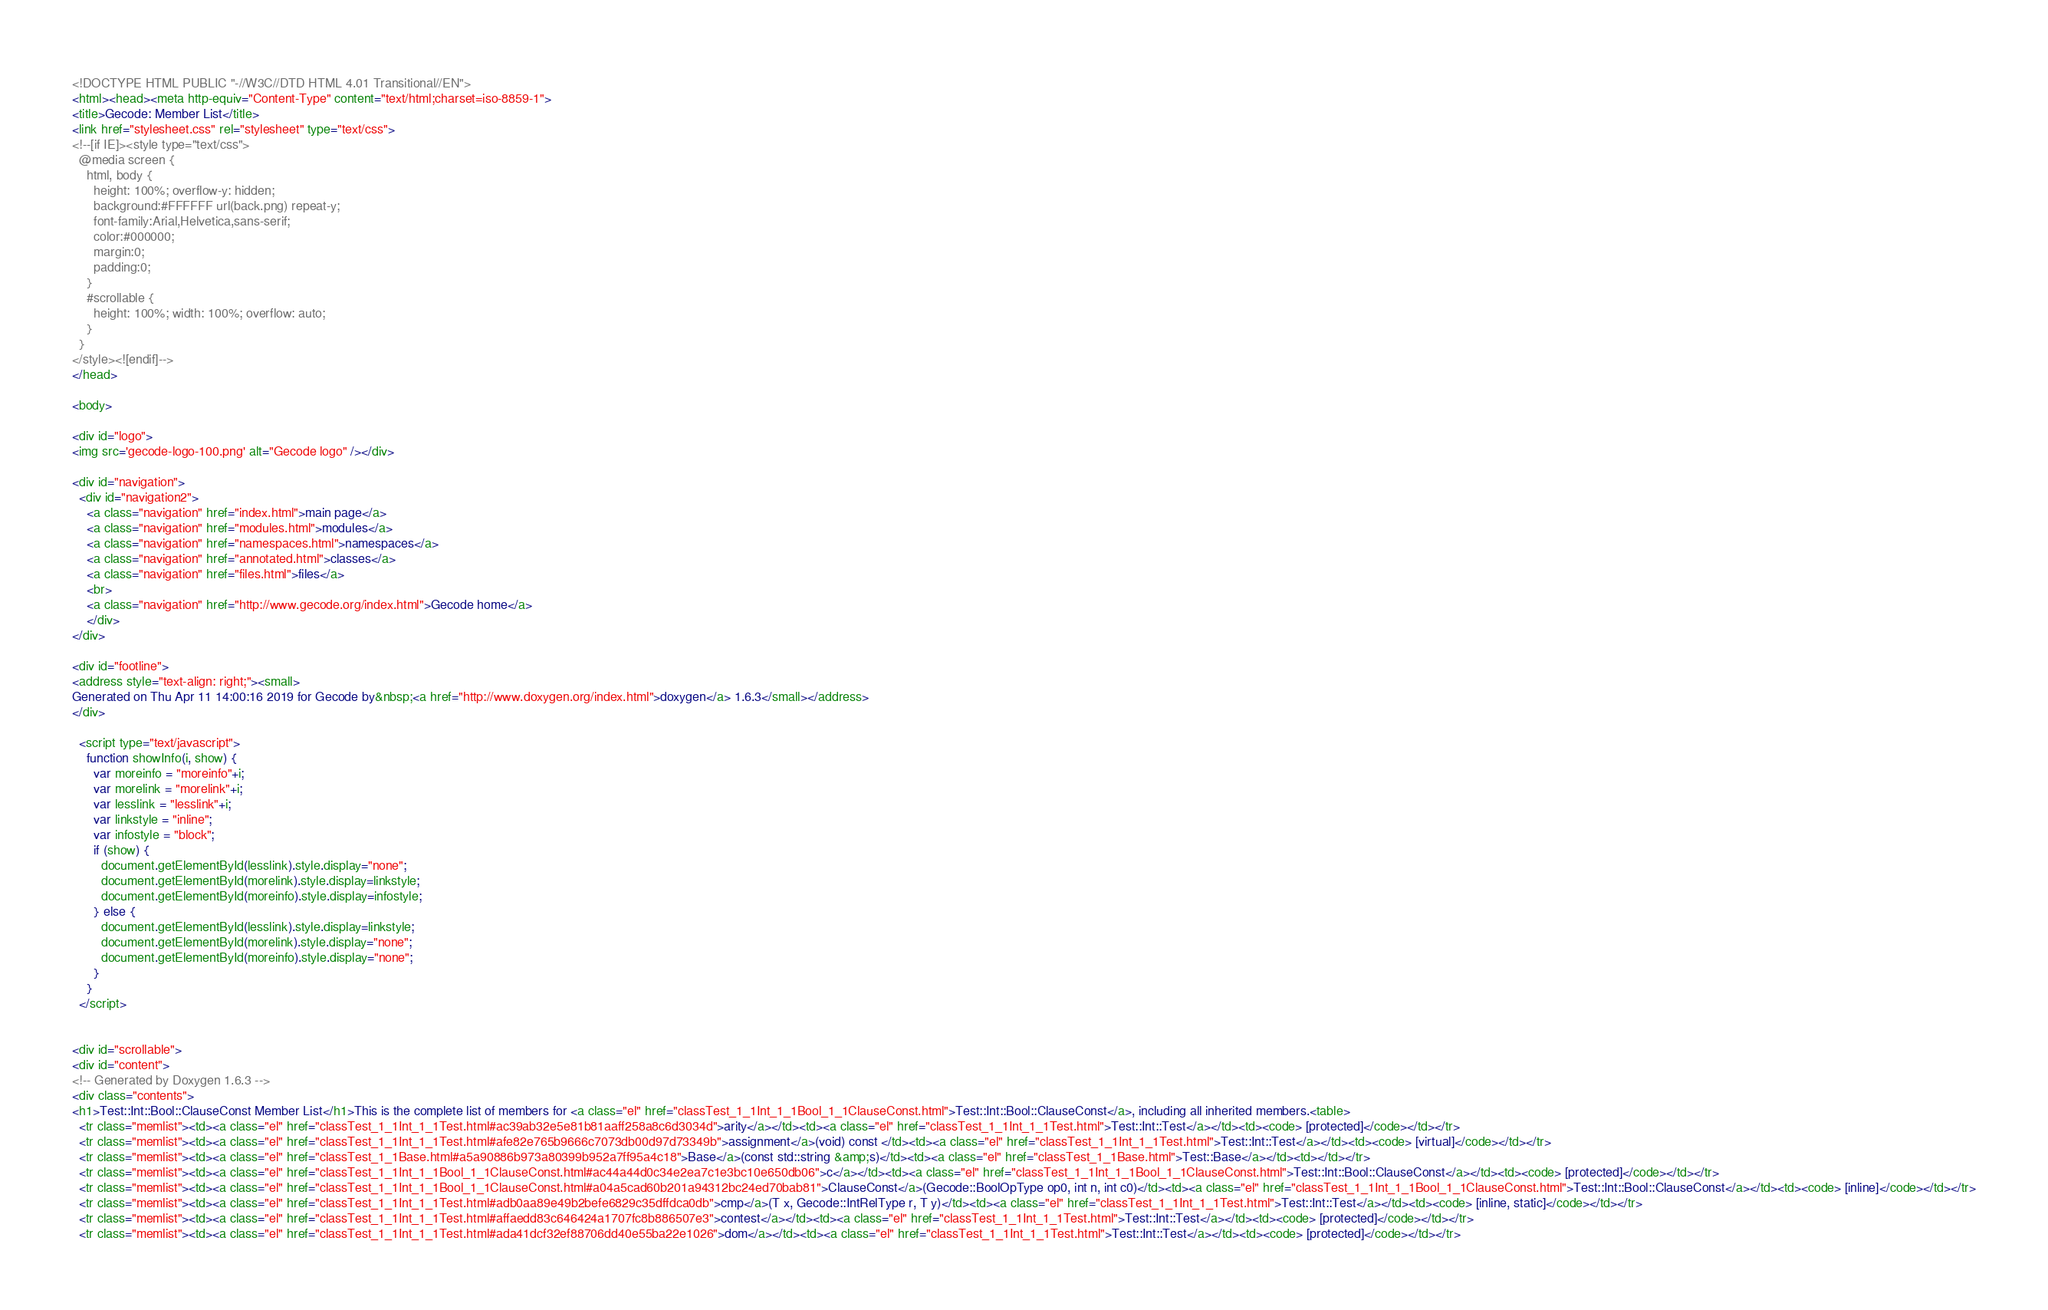Convert code to text. <code><loc_0><loc_0><loc_500><loc_500><_HTML_><!DOCTYPE HTML PUBLIC "-//W3C//DTD HTML 4.01 Transitional//EN">
<html><head><meta http-equiv="Content-Type" content="text/html;charset=iso-8859-1">
<title>Gecode: Member List</title>
<link href="stylesheet.css" rel="stylesheet" type="text/css">
<!--[if IE]><style type="text/css">
  @media screen {
    html, body {
      height: 100%; overflow-y: hidden;
      background:#FFFFFF url(back.png) repeat-y;
      font-family:Arial,Helvetica,sans-serif;
      color:#000000;
      margin:0;
      padding:0;
    }
    #scrollable {
      height: 100%; width: 100%; overflow: auto;
    }
  }
</style><![endif]-->
</head>

<body>

<div id="logo">
<img src='gecode-logo-100.png' alt="Gecode logo" /></div>

<div id="navigation">
  <div id="navigation2">
    <a class="navigation" href="index.html">main page</a>
    <a class="navigation" href="modules.html">modules</a>
    <a class="navigation" href="namespaces.html">namespaces</a>
    <a class="navigation" href="annotated.html">classes</a>
    <a class="navigation" href="files.html">files</a>
    <br>
    <a class="navigation" href="http://www.gecode.org/index.html">Gecode home</a>
    </div>
</div>

<div id="footline">
<address style="text-align: right;"><small>
Generated on Thu Apr 11 14:00:16 2019 for Gecode by&nbsp;<a href="http://www.doxygen.org/index.html">doxygen</a> 1.6.3</small></address>
</div>

  <script type="text/javascript">
    function showInfo(i, show) {
      var moreinfo = "moreinfo"+i;
      var morelink = "morelink"+i;
      var lesslink = "lesslink"+i;
      var linkstyle = "inline";
      var infostyle = "block";
      if (show) {
        document.getElementById(lesslink).style.display="none";
        document.getElementById(morelink).style.display=linkstyle;
        document.getElementById(moreinfo).style.display=infostyle;
      } else {
        document.getElementById(lesslink).style.display=linkstyle;
        document.getElementById(morelink).style.display="none";
        document.getElementById(moreinfo).style.display="none";
      }
    }
  </script>


<div id="scrollable">
<div id="content">
<!-- Generated by Doxygen 1.6.3 -->
<div class="contents">
<h1>Test::Int::Bool::ClauseConst Member List</h1>This is the complete list of members for <a class="el" href="classTest_1_1Int_1_1Bool_1_1ClauseConst.html">Test::Int::Bool::ClauseConst</a>, including all inherited members.<table>
  <tr class="memlist"><td><a class="el" href="classTest_1_1Int_1_1Test.html#ac39ab32e5e81b81aaff258a8c6d3034d">arity</a></td><td><a class="el" href="classTest_1_1Int_1_1Test.html">Test::Int::Test</a></td><td><code> [protected]</code></td></tr>
  <tr class="memlist"><td><a class="el" href="classTest_1_1Int_1_1Test.html#afe82e765b9666c7073db00d97d73349b">assignment</a>(void) const </td><td><a class="el" href="classTest_1_1Int_1_1Test.html">Test::Int::Test</a></td><td><code> [virtual]</code></td></tr>
  <tr class="memlist"><td><a class="el" href="classTest_1_1Base.html#a5a90886b973a80399b952a7ff95a4c18">Base</a>(const std::string &amp;s)</td><td><a class="el" href="classTest_1_1Base.html">Test::Base</a></td><td></td></tr>
  <tr class="memlist"><td><a class="el" href="classTest_1_1Int_1_1Bool_1_1ClauseConst.html#ac44a44d0c34e2ea7c1e3bc10e650db06">c</a></td><td><a class="el" href="classTest_1_1Int_1_1Bool_1_1ClauseConst.html">Test::Int::Bool::ClauseConst</a></td><td><code> [protected]</code></td></tr>
  <tr class="memlist"><td><a class="el" href="classTest_1_1Int_1_1Bool_1_1ClauseConst.html#a04a5cad60b201a94312bc24ed70bab81">ClauseConst</a>(Gecode::BoolOpType op0, int n, int c0)</td><td><a class="el" href="classTest_1_1Int_1_1Bool_1_1ClauseConst.html">Test::Int::Bool::ClauseConst</a></td><td><code> [inline]</code></td></tr>
  <tr class="memlist"><td><a class="el" href="classTest_1_1Int_1_1Test.html#adb0aa89e49b2befe6829c35dffdca0db">cmp</a>(T x, Gecode::IntRelType r, T y)</td><td><a class="el" href="classTest_1_1Int_1_1Test.html">Test::Int::Test</a></td><td><code> [inline, static]</code></td></tr>
  <tr class="memlist"><td><a class="el" href="classTest_1_1Int_1_1Test.html#affaedd83c646424a1707fc8b886507e3">contest</a></td><td><a class="el" href="classTest_1_1Int_1_1Test.html">Test::Int::Test</a></td><td><code> [protected]</code></td></tr>
  <tr class="memlist"><td><a class="el" href="classTest_1_1Int_1_1Test.html#ada41dcf32ef88706dd40e55ba22e1026">dom</a></td><td><a class="el" href="classTest_1_1Int_1_1Test.html">Test::Int::Test</a></td><td><code> [protected]</code></td></tr></code> 